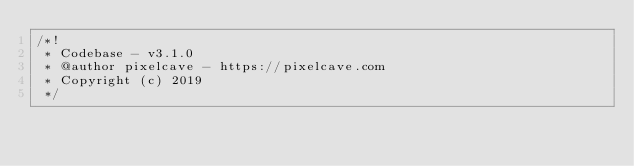<code> <loc_0><loc_0><loc_500><loc_500><_JavaScript_>/*!
 * Codebase - v3.1.0
 * @author pixelcave - https://pixelcave.com
 * Copyright (c) 2019
 */</code> 